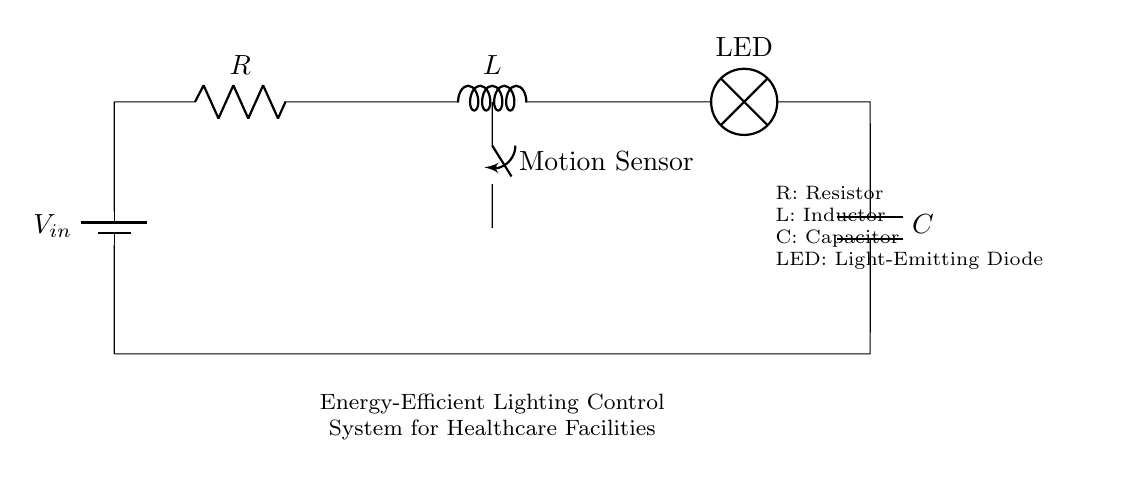What components are in this circuit? The circuit contains a resistor, an inductor, a capacitor, a light-emitting diode, and a motion sensor. These components are clearly labeled in the diagram.
Answer: Resistor, Inductor, Capacitor, LED, Motion Sensor What component controls the lighting based on movement? The motion sensor is the component that detects movement and controls the lighting in the circuit. It is positioned as a switch before the LED in the diagram.
Answer: Motion Sensor What type of circuit is represented? The circuit is a Resistor-Inductor-Capacitor circuit, as indicated by the labeled components R, L, and C working together to form a dynamic lighting control system.
Answer: Resistor-Inductor-Capacitor What is the function of the LED in this circuit? The LED acts as a light source, providing illumination when the circuit is powered and motion is detected. Its position in the diagram shows it receives power from the components to emit light.
Answer: Light source How does the inductor affect the performance of the lighting system? The inductor can affect the circuit's response time and stability by storing energy in a magnetic field, which influences the current flow to the LED and consequently the lighting behavior.
Answer: Stability What effect does adding more resistance have on the circuit? Increasing resistance will decrease the current flowing through the circuit according to Ohm's law, which may reduce the brightness of the LED when it is illuminated.
Answer: Decreases current What role does the capacitor play in this RLC circuit? The capacitor stores energy and can smooth out voltage fluctuations, providing more stable lighting by discharging when needed to maintain consistent current levels to the LED.
Answer: Energy storage 